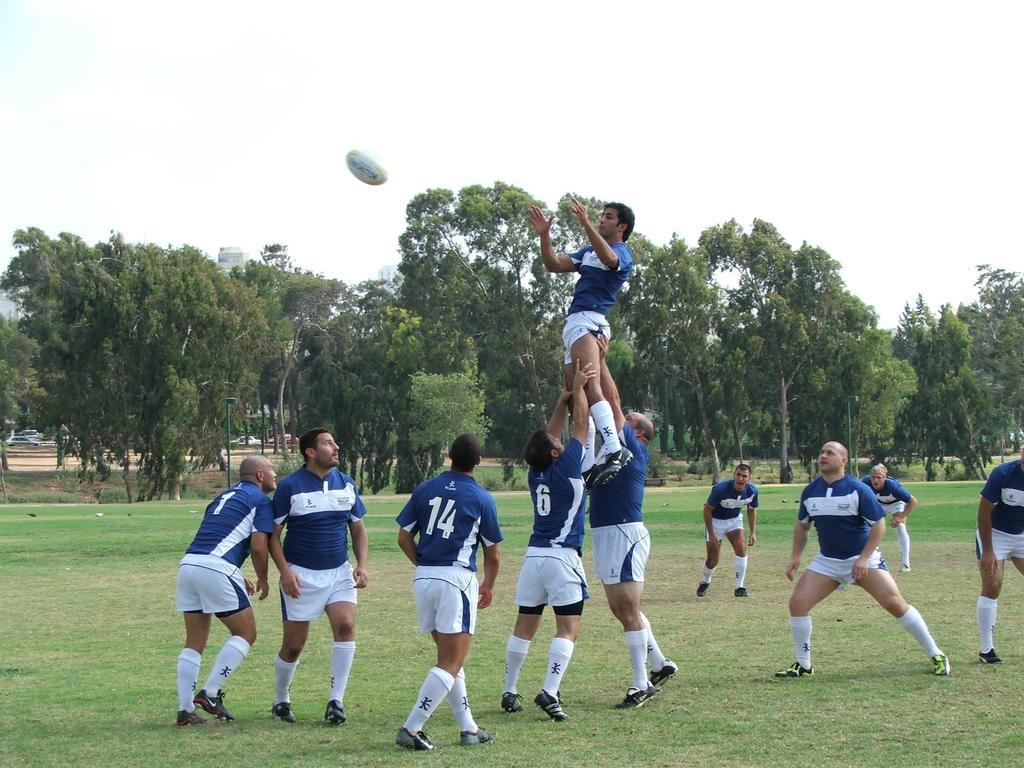<image>
Present a compact description of the photo's key features. A player with a 6 on his uniform helps lift another player aloft. 